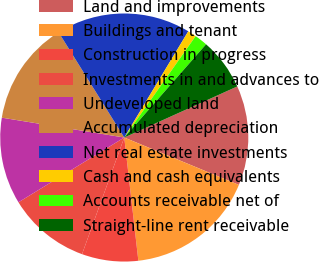Convert chart to OTSL. <chart><loc_0><loc_0><loc_500><loc_500><pie_chart><fcel>Land and improvements<fcel>Buildings and tenant<fcel>Construction in progress<fcel>Investments in and advances to<fcel>Undeveloped land<fcel>Accumulated depreciation<fcel>Net real estate investments<fcel>Cash and cash equivalents<fcel>Accounts receivable net of<fcel>Straight-line rent receivable<nl><fcel>12.99%<fcel>16.95%<fcel>7.34%<fcel>10.73%<fcel>11.3%<fcel>13.56%<fcel>17.51%<fcel>1.13%<fcel>1.7%<fcel>6.78%<nl></chart> 